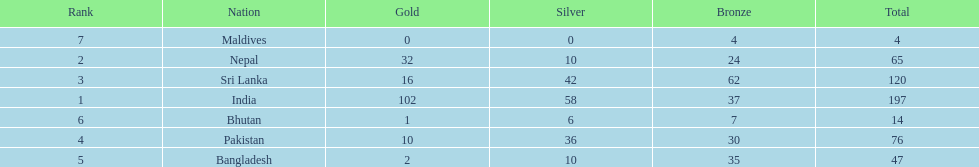How many more gold medals has nepal won than pakistan? 22. 